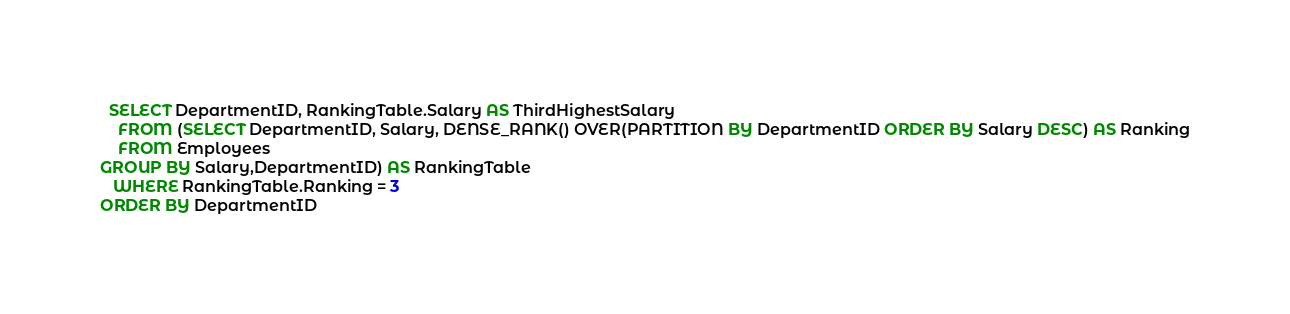Convert code to text. <code><loc_0><loc_0><loc_500><loc_500><_SQL_>  SELECT DepartmentID, RankingTable.Salary AS ThirdHighestSalary 
    FROM (SELECT DepartmentID, Salary, DENSE_RANK() OVER(PARTITION BY DepartmentID ORDER BY Salary DESC) AS Ranking
    FROM Employees
GROUP BY Salary,DepartmentID) AS RankingTable
   WHERE RankingTable.Ranking = 3
ORDER BY DepartmentID</code> 